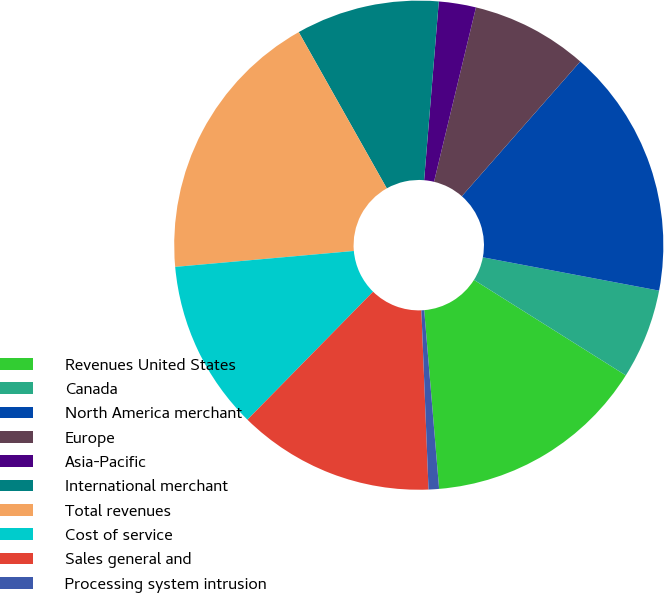Convert chart. <chart><loc_0><loc_0><loc_500><loc_500><pie_chart><fcel>Revenues United States<fcel>Canada<fcel>North America merchant<fcel>Europe<fcel>Asia-Pacific<fcel>International merchant<fcel>Total revenues<fcel>Cost of service<fcel>Sales general and<fcel>Processing system intrusion<nl><fcel>14.74%<fcel>5.96%<fcel>16.5%<fcel>7.72%<fcel>2.45%<fcel>9.47%<fcel>18.25%<fcel>11.23%<fcel>12.99%<fcel>0.69%<nl></chart> 